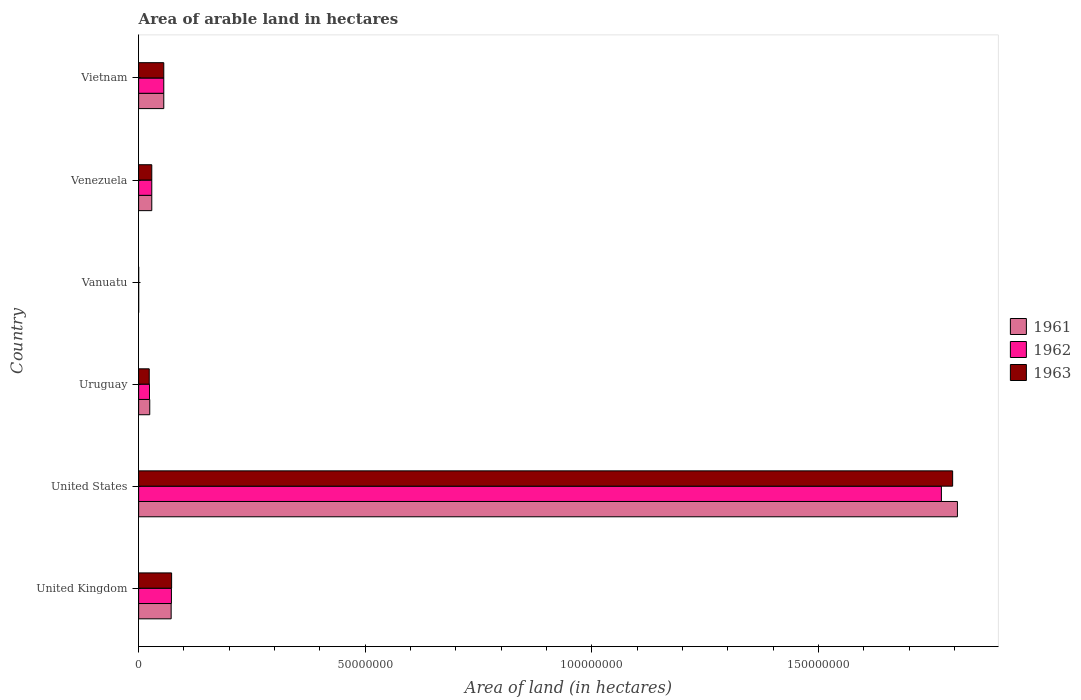How many different coloured bars are there?
Make the answer very short. 3. Are the number of bars per tick equal to the number of legend labels?
Your answer should be very brief. Yes. How many bars are there on the 3rd tick from the top?
Make the answer very short. 3. In how many cases, is the number of bars for a given country not equal to the number of legend labels?
Offer a terse response. 0. Across all countries, what is the maximum total arable land in 1962?
Make the answer very short. 1.77e+08. Across all countries, what is the minimum total arable land in 1961?
Your answer should be compact. 10000. In which country was the total arable land in 1963 minimum?
Ensure brevity in your answer.  Vanuatu. What is the total total arable land in 1963 in the graph?
Your response must be concise. 1.98e+08. What is the difference between the total arable land in 1963 in Uruguay and that in Vanuatu?
Ensure brevity in your answer.  2.33e+06. What is the difference between the total arable land in 1963 in United Kingdom and the total arable land in 1961 in Vanuatu?
Keep it short and to the point. 7.26e+06. What is the average total arable land in 1963 per country?
Keep it short and to the point. 3.29e+07. What is the difference between the total arable land in 1963 and total arable land in 1962 in Uruguay?
Keep it short and to the point. -5.80e+04. What is the ratio of the total arable land in 1962 in United States to that in Venezuela?
Keep it short and to the point. 61.07. What is the difference between the highest and the second highest total arable land in 1962?
Your answer should be very brief. 1.70e+08. What is the difference between the highest and the lowest total arable land in 1963?
Your answer should be very brief. 1.80e+08. In how many countries, is the total arable land in 1962 greater than the average total arable land in 1962 taken over all countries?
Ensure brevity in your answer.  1. What does the 3rd bar from the top in Vanuatu represents?
Your answer should be compact. 1961. Is it the case that in every country, the sum of the total arable land in 1961 and total arable land in 1963 is greater than the total arable land in 1962?
Your answer should be very brief. Yes. How many countries are there in the graph?
Provide a short and direct response. 6. What is the difference between two consecutive major ticks on the X-axis?
Your answer should be compact. 5.00e+07. Are the values on the major ticks of X-axis written in scientific E-notation?
Your response must be concise. No. Does the graph contain any zero values?
Offer a very short reply. No. Where does the legend appear in the graph?
Ensure brevity in your answer.  Center right. What is the title of the graph?
Your answer should be very brief. Area of arable land in hectares. What is the label or title of the X-axis?
Give a very brief answer. Area of land (in hectares). What is the label or title of the Y-axis?
Your answer should be very brief. Country. What is the Area of land (in hectares) of 1961 in United Kingdom?
Provide a short and direct response. 7.18e+06. What is the Area of land (in hectares) of 1962 in United Kingdom?
Offer a terse response. 7.24e+06. What is the Area of land (in hectares) of 1963 in United Kingdom?
Provide a succinct answer. 7.28e+06. What is the Area of land (in hectares) in 1961 in United States?
Your response must be concise. 1.81e+08. What is the Area of land (in hectares) in 1962 in United States?
Make the answer very short. 1.77e+08. What is the Area of land (in hectares) of 1963 in United States?
Your response must be concise. 1.80e+08. What is the Area of land (in hectares) of 1961 in Uruguay?
Ensure brevity in your answer.  2.45e+06. What is the Area of land (in hectares) in 1962 in Uruguay?
Your response must be concise. 2.40e+06. What is the Area of land (in hectares) of 1963 in Uruguay?
Provide a short and direct response. 2.34e+06. What is the Area of land (in hectares) of 1963 in Vanuatu?
Your answer should be very brief. 10000. What is the Area of land (in hectares) of 1961 in Venezuela?
Your answer should be very brief. 2.90e+06. What is the Area of land (in hectares) of 1962 in Venezuela?
Provide a succinct answer. 2.90e+06. What is the Area of land (in hectares) of 1963 in Venezuela?
Provide a short and direct response. 2.90e+06. What is the Area of land (in hectares) of 1961 in Vietnam?
Your answer should be compact. 5.55e+06. What is the Area of land (in hectares) in 1962 in Vietnam?
Ensure brevity in your answer.  5.55e+06. What is the Area of land (in hectares) of 1963 in Vietnam?
Provide a short and direct response. 5.55e+06. Across all countries, what is the maximum Area of land (in hectares) of 1961?
Give a very brief answer. 1.81e+08. Across all countries, what is the maximum Area of land (in hectares) in 1962?
Give a very brief answer. 1.77e+08. Across all countries, what is the maximum Area of land (in hectares) in 1963?
Provide a short and direct response. 1.80e+08. Across all countries, what is the minimum Area of land (in hectares) of 1961?
Keep it short and to the point. 10000. Across all countries, what is the minimum Area of land (in hectares) of 1963?
Make the answer very short. 10000. What is the total Area of land (in hectares) in 1961 in the graph?
Your answer should be very brief. 1.99e+08. What is the total Area of land (in hectares) in 1962 in the graph?
Ensure brevity in your answer.  1.95e+08. What is the total Area of land (in hectares) of 1963 in the graph?
Ensure brevity in your answer.  1.98e+08. What is the difference between the Area of land (in hectares) in 1961 in United Kingdom and that in United States?
Your response must be concise. -1.73e+08. What is the difference between the Area of land (in hectares) of 1962 in United Kingdom and that in United States?
Keep it short and to the point. -1.70e+08. What is the difference between the Area of land (in hectares) in 1963 in United Kingdom and that in United States?
Keep it short and to the point. -1.72e+08. What is the difference between the Area of land (in hectares) in 1961 in United Kingdom and that in Uruguay?
Keep it short and to the point. 4.72e+06. What is the difference between the Area of land (in hectares) in 1962 in United Kingdom and that in Uruguay?
Your answer should be very brief. 4.84e+06. What is the difference between the Area of land (in hectares) in 1963 in United Kingdom and that in Uruguay?
Offer a terse response. 4.94e+06. What is the difference between the Area of land (in hectares) of 1961 in United Kingdom and that in Vanuatu?
Provide a short and direct response. 7.16e+06. What is the difference between the Area of land (in hectares) of 1962 in United Kingdom and that in Vanuatu?
Keep it short and to the point. 7.23e+06. What is the difference between the Area of land (in hectares) of 1963 in United Kingdom and that in Vanuatu?
Give a very brief answer. 7.26e+06. What is the difference between the Area of land (in hectares) in 1961 in United Kingdom and that in Venezuela?
Your answer should be very brief. 4.28e+06. What is the difference between the Area of land (in hectares) in 1962 in United Kingdom and that in Venezuela?
Ensure brevity in your answer.  4.34e+06. What is the difference between the Area of land (in hectares) in 1963 in United Kingdom and that in Venezuela?
Give a very brief answer. 4.37e+06. What is the difference between the Area of land (in hectares) of 1961 in United Kingdom and that in Vietnam?
Provide a succinct answer. 1.62e+06. What is the difference between the Area of land (in hectares) in 1962 in United Kingdom and that in Vietnam?
Ensure brevity in your answer.  1.69e+06. What is the difference between the Area of land (in hectares) of 1963 in United Kingdom and that in Vietnam?
Ensure brevity in your answer.  1.72e+06. What is the difference between the Area of land (in hectares) of 1961 in United States and that in Uruguay?
Keep it short and to the point. 1.78e+08. What is the difference between the Area of land (in hectares) of 1962 in United States and that in Uruguay?
Offer a very short reply. 1.75e+08. What is the difference between the Area of land (in hectares) of 1963 in United States and that in Uruguay?
Your response must be concise. 1.77e+08. What is the difference between the Area of land (in hectares) of 1961 in United States and that in Vanuatu?
Your answer should be very brief. 1.81e+08. What is the difference between the Area of land (in hectares) in 1962 in United States and that in Vanuatu?
Provide a short and direct response. 1.77e+08. What is the difference between the Area of land (in hectares) in 1963 in United States and that in Vanuatu?
Provide a short and direct response. 1.80e+08. What is the difference between the Area of land (in hectares) of 1961 in United States and that in Venezuela?
Your response must be concise. 1.78e+08. What is the difference between the Area of land (in hectares) in 1962 in United States and that in Venezuela?
Your response must be concise. 1.74e+08. What is the difference between the Area of land (in hectares) in 1963 in United States and that in Venezuela?
Ensure brevity in your answer.  1.77e+08. What is the difference between the Area of land (in hectares) in 1961 in United States and that in Vietnam?
Provide a succinct answer. 1.75e+08. What is the difference between the Area of land (in hectares) in 1962 in United States and that in Vietnam?
Keep it short and to the point. 1.72e+08. What is the difference between the Area of land (in hectares) of 1963 in United States and that in Vietnam?
Make the answer very short. 1.74e+08. What is the difference between the Area of land (in hectares) in 1961 in Uruguay and that in Vanuatu?
Your answer should be compact. 2.44e+06. What is the difference between the Area of land (in hectares) in 1962 in Uruguay and that in Vanuatu?
Your answer should be very brief. 2.39e+06. What is the difference between the Area of land (in hectares) in 1963 in Uruguay and that in Vanuatu?
Offer a very short reply. 2.33e+06. What is the difference between the Area of land (in hectares) of 1961 in Uruguay and that in Venezuela?
Provide a short and direct response. -4.46e+05. What is the difference between the Area of land (in hectares) in 1962 in Uruguay and that in Venezuela?
Ensure brevity in your answer.  -5.04e+05. What is the difference between the Area of land (in hectares) of 1963 in Uruguay and that in Venezuela?
Keep it short and to the point. -5.65e+05. What is the difference between the Area of land (in hectares) of 1961 in Uruguay and that in Vietnam?
Provide a succinct answer. -3.10e+06. What is the difference between the Area of land (in hectares) in 1962 in Uruguay and that in Vietnam?
Provide a succinct answer. -3.15e+06. What is the difference between the Area of land (in hectares) of 1963 in Uruguay and that in Vietnam?
Your answer should be very brief. -3.21e+06. What is the difference between the Area of land (in hectares) in 1961 in Vanuatu and that in Venezuela?
Provide a short and direct response. -2.89e+06. What is the difference between the Area of land (in hectares) of 1962 in Vanuatu and that in Venezuela?
Keep it short and to the point. -2.89e+06. What is the difference between the Area of land (in hectares) of 1963 in Vanuatu and that in Venezuela?
Offer a terse response. -2.89e+06. What is the difference between the Area of land (in hectares) in 1961 in Vanuatu and that in Vietnam?
Your response must be concise. -5.54e+06. What is the difference between the Area of land (in hectares) of 1962 in Vanuatu and that in Vietnam?
Your answer should be compact. -5.54e+06. What is the difference between the Area of land (in hectares) in 1963 in Vanuatu and that in Vietnam?
Provide a succinct answer. -5.54e+06. What is the difference between the Area of land (in hectares) in 1961 in Venezuela and that in Vietnam?
Make the answer very short. -2.65e+06. What is the difference between the Area of land (in hectares) of 1962 in Venezuela and that in Vietnam?
Make the answer very short. -2.65e+06. What is the difference between the Area of land (in hectares) in 1963 in Venezuela and that in Vietnam?
Your response must be concise. -2.65e+06. What is the difference between the Area of land (in hectares) in 1961 in United Kingdom and the Area of land (in hectares) in 1962 in United States?
Your answer should be very brief. -1.70e+08. What is the difference between the Area of land (in hectares) in 1961 in United Kingdom and the Area of land (in hectares) in 1963 in United States?
Offer a very short reply. -1.72e+08. What is the difference between the Area of land (in hectares) of 1962 in United Kingdom and the Area of land (in hectares) of 1963 in United States?
Provide a short and direct response. -1.72e+08. What is the difference between the Area of land (in hectares) in 1961 in United Kingdom and the Area of land (in hectares) in 1962 in Uruguay?
Provide a short and direct response. 4.78e+06. What is the difference between the Area of land (in hectares) in 1961 in United Kingdom and the Area of land (in hectares) in 1963 in Uruguay?
Your answer should be very brief. 4.84e+06. What is the difference between the Area of land (in hectares) of 1962 in United Kingdom and the Area of land (in hectares) of 1963 in Uruguay?
Offer a terse response. 4.90e+06. What is the difference between the Area of land (in hectares) of 1961 in United Kingdom and the Area of land (in hectares) of 1962 in Vanuatu?
Offer a very short reply. 7.16e+06. What is the difference between the Area of land (in hectares) of 1961 in United Kingdom and the Area of land (in hectares) of 1963 in Vanuatu?
Provide a short and direct response. 7.16e+06. What is the difference between the Area of land (in hectares) in 1962 in United Kingdom and the Area of land (in hectares) in 1963 in Vanuatu?
Your answer should be very brief. 7.23e+06. What is the difference between the Area of land (in hectares) in 1961 in United Kingdom and the Area of land (in hectares) in 1962 in Venezuela?
Provide a succinct answer. 4.28e+06. What is the difference between the Area of land (in hectares) in 1961 in United Kingdom and the Area of land (in hectares) in 1963 in Venezuela?
Ensure brevity in your answer.  4.27e+06. What is the difference between the Area of land (in hectares) of 1962 in United Kingdom and the Area of land (in hectares) of 1963 in Venezuela?
Give a very brief answer. 4.33e+06. What is the difference between the Area of land (in hectares) in 1961 in United Kingdom and the Area of land (in hectares) in 1962 in Vietnam?
Your answer should be very brief. 1.62e+06. What is the difference between the Area of land (in hectares) in 1961 in United Kingdom and the Area of land (in hectares) in 1963 in Vietnam?
Your response must be concise. 1.62e+06. What is the difference between the Area of land (in hectares) in 1962 in United Kingdom and the Area of land (in hectares) in 1963 in Vietnam?
Give a very brief answer. 1.69e+06. What is the difference between the Area of land (in hectares) of 1961 in United States and the Area of land (in hectares) of 1962 in Uruguay?
Your answer should be very brief. 1.78e+08. What is the difference between the Area of land (in hectares) of 1961 in United States and the Area of land (in hectares) of 1963 in Uruguay?
Provide a succinct answer. 1.78e+08. What is the difference between the Area of land (in hectares) of 1962 in United States and the Area of land (in hectares) of 1963 in Uruguay?
Offer a terse response. 1.75e+08. What is the difference between the Area of land (in hectares) of 1961 in United States and the Area of land (in hectares) of 1962 in Vanuatu?
Ensure brevity in your answer.  1.81e+08. What is the difference between the Area of land (in hectares) of 1961 in United States and the Area of land (in hectares) of 1963 in Vanuatu?
Ensure brevity in your answer.  1.81e+08. What is the difference between the Area of land (in hectares) in 1962 in United States and the Area of land (in hectares) in 1963 in Vanuatu?
Keep it short and to the point. 1.77e+08. What is the difference between the Area of land (in hectares) in 1961 in United States and the Area of land (in hectares) in 1962 in Venezuela?
Ensure brevity in your answer.  1.78e+08. What is the difference between the Area of land (in hectares) of 1961 in United States and the Area of land (in hectares) of 1963 in Venezuela?
Keep it short and to the point. 1.78e+08. What is the difference between the Area of land (in hectares) in 1962 in United States and the Area of land (in hectares) in 1963 in Venezuela?
Make the answer very short. 1.74e+08. What is the difference between the Area of land (in hectares) in 1961 in United States and the Area of land (in hectares) in 1962 in Vietnam?
Keep it short and to the point. 1.75e+08. What is the difference between the Area of land (in hectares) in 1961 in United States and the Area of land (in hectares) in 1963 in Vietnam?
Your answer should be very brief. 1.75e+08. What is the difference between the Area of land (in hectares) of 1962 in United States and the Area of land (in hectares) of 1963 in Vietnam?
Your answer should be very brief. 1.72e+08. What is the difference between the Area of land (in hectares) of 1961 in Uruguay and the Area of land (in hectares) of 1962 in Vanuatu?
Offer a terse response. 2.44e+06. What is the difference between the Area of land (in hectares) in 1961 in Uruguay and the Area of land (in hectares) in 1963 in Vanuatu?
Offer a very short reply. 2.44e+06. What is the difference between the Area of land (in hectares) of 1962 in Uruguay and the Area of land (in hectares) of 1963 in Vanuatu?
Your answer should be very brief. 2.39e+06. What is the difference between the Area of land (in hectares) in 1961 in Uruguay and the Area of land (in hectares) in 1962 in Venezuela?
Your response must be concise. -4.46e+05. What is the difference between the Area of land (in hectares) in 1961 in Uruguay and the Area of land (in hectares) in 1963 in Venezuela?
Your response must be concise. -4.49e+05. What is the difference between the Area of land (in hectares) in 1962 in Uruguay and the Area of land (in hectares) in 1963 in Venezuela?
Ensure brevity in your answer.  -5.07e+05. What is the difference between the Area of land (in hectares) in 1961 in Uruguay and the Area of land (in hectares) in 1962 in Vietnam?
Provide a succinct answer. -3.10e+06. What is the difference between the Area of land (in hectares) in 1961 in Uruguay and the Area of land (in hectares) in 1963 in Vietnam?
Keep it short and to the point. -3.10e+06. What is the difference between the Area of land (in hectares) of 1962 in Uruguay and the Area of land (in hectares) of 1963 in Vietnam?
Keep it short and to the point. -3.15e+06. What is the difference between the Area of land (in hectares) in 1961 in Vanuatu and the Area of land (in hectares) in 1962 in Venezuela?
Offer a very short reply. -2.89e+06. What is the difference between the Area of land (in hectares) of 1961 in Vanuatu and the Area of land (in hectares) of 1963 in Venezuela?
Offer a terse response. -2.89e+06. What is the difference between the Area of land (in hectares) of 1962 in Vanuatu and the Area of land (in hectares) of 1963 in Venezuela?
Provide a succinct answer. -2.89e+06. What is the difference between the Area of land (in hectares) of 1961 in Vanuatu and the Area of land (in hectares) of 1962 in Vietnam?
Make the answer very short. -5.54e+06. What is the difference between the Area of land (in hectares) in 1961 in Vanuatu and the Area of land (in hectares) in 1963 in Vietnam?
Offer a very short reply. -5.54e+06. What is the difference between the Area of land (in hectares) in 1962 in Vanuatu and the Area of land (in hectares) in 1963 in Vietnam?
Offer a terse response. -5.54e+06. What is the difference between the Area of land (in hectares) in 1961 in Venezuela and the Area of land (in hectares) in 1962 in Vietnam?
Offer a very short reply. -2.65e+06. What is the difference between the Area of land (in hectares) in 1961 in Venezuela and the Area of land (in hectares) in 1963 in Vietnam?
Offer a very short reply. -2.65e+06. What is the difference between the Area of land (in hectares) of 1962 in Venezuela and the Area of land (in hectares) of 1963 in Vietnam?
Give a very brief answer. -2.65e+06. What is the average Area of land (in hectares) in 1961 per country?
Your response must be concise. 3.31e+07. What is the average Area of land (in hectares) in 1962 per country?
Ensure brevity in your answer.  3.25e+07. What is the average Area of land (in hectares) in 1963 per country?
Give a very brief answer. 3.29e+07. What is the difference between the Area of land (in hectares) of 1961 and Area of land (in hectares) of 1962 in United Kingdom?
Provide a short and direct response. -6.10e+04. What is the difference between the Area of land (in hectares) of 1961 and Area of land (in hectares) of 1963 in United Kingdom?
Your answer should be very brief. -1.00e+05. What is the difference between the Area of land (in hectares) in 1962 and Area of land (in hectares) in 1963 in United Kingdom?
Offer a very short reply. -3.90e+04. What is the difference between the Area of land (in hectares) of 1961 and Area of land (in hectares) of 1962 in United States?
Ensure brevity in your answer.  3.54e+06. What is the difference between the Area of land (in hectares) in 1961 and Area of land (in hectares) in 1963 in United States?
Your answer should be very brief. 1.06e+06. What is the difference between the Area of land (in hectares) in 1962 and Area of land (in hectares) in 1963 in United States?
Ensure brevity in your answer.  -2.48e+06. What is the difference between the Area of land (in hectares) of 1961 and Area of land (in hectares) of 1962 in Uruguay?
Provide a succinct answer. 5.80e+04. What is the difference between the Area of land (in hectares) in 1961 and Area of land (in hectares) in 1963 in Uruguay?
Offer a very short reply. 1.16e+05. What is the difference between the Area of land (in hectares) of 1962 and Area of land (in hectares) of 1963 in Uruguay?
Provide a succinct answer. 5.80e+04. What is the difference between the Area of land (in hectares) in 1961 and Area of land (in hectares) in 1962 in Vanuatu?
Your response must be concise. 0. What is the difference between the Area of land (in hectares) in 1961 and Area of land (in hectares) in 1963 in Vanuatu?
Your answer should be very brief. 0. What is the difference between the Area of land (in hectares) of 1961 and Area of land (in hectares) of 1963 in Venezuela?
Provide a short and direct response. -3000. What is the difference between the Area of land (in hectares) of 1962 and Area of land (in hectares) of 1963 in Venezuela?
Your answer should be compact. -3000. What is the difference between the Area of land (in hectares) of 1962 and Area of land (in hectares) of 1963 in Vietnam?
Offer a very short reply. 0. What is the ratio of the Area of land (in hectares) of 1961 in United Kingdom to that in United States?
Make the answer very short. 0.04. What is the ratio of the Area of land (in hectares) in 1962 in United Kingdom to that in United States?
Your answer should be very brief. 0.04. What is the ratio of the Area of land (in hectares) of 1963 in United Kingdom to that in United States?
Offer a terse response. 0.04. What is the ratio of the Area of land (in hectares) in 1961 in United Kingdom to that in Uruguay?
Keep it short and to the point. 2.92. What is the ratio of the Area of land (in hectares) of 1962 in United Kingdom to that in Uruguay?
Your answer should be very brief. 3.02. What is the ratio of the Area of land (in hectares) of 1963 in United Kingdom to that in Uruguay?
Your answer should be very brief. 3.11. What is the ratio of the Area of land (in hectares) in 1961 in United Kingdom to that in Vanuatu?
Your answer should be very brief. 717.5. What is the ratio of the Area of land (in hectares) of 1962 in United Kingdom to that in Vanuatu?
Provide a short and direct response. 723.6. What is the ratio of the Area of land (in hectares) in 1963 in United Kingdom to that in Vanuatu?
Your answer should be compact. 727.5. What is the ratio of the Area of land (in hectares) in 1961 in United Kingdom to that in Venezuela?
Keep it short and to the point. 2.47. What is the ratio of the Area of land (in hectares) of 1962 in United Kingdom to that in Venezuela?
Provide a succinct answer. 2.5. What is the ratio of the Area of land (in hectares) in 1963 in United Kingdom to that in Venezuela?
Offer a terse response. 2.51. What is the ratio of the Area of land (in hectares) of 1961 in United Kingdom to that in Vietnam?
Provide a short and direct response. 1.29. What is the ratio of the Area of land (in hectares) in 1962 in United Kingdom to that in Vietnam?
Offer a terse response. 1.3. What is the ratio of the Area of land (in hectares) in 1963 in United Kingdom to that in Vietnam?
Your answer should be very brief. 1.31. What is the ratio of the Area of land (in hectares) of 1961 in United States to that in Uruguay?
Keep it short and to the point. 73.61. What is the ratio of the Area of land (in hectares) in 1962 in United States to that in Uruguay?
Make the answer very short. 73.91. What is the ratio of the Area of land (in hectares) in 1963 in United States to that in Uruguay?
Your answer should be compact. 76.81. What is the ratio of the Area of land (in hectares) in 1961 in United States to that in Vanuatu?
Provide a short and direct response. 1.81e+04. What is the ratio of the Area of land (in hectares) of 1962 in United States to that in Vanuatu?
Offer a very short reply. 1.77e+04. What is the ratio of the Area of land (in hectares) of 1963 in United States to that in Vanuatu?
Make the answer very short. 1.80e+04. What is the ratio of the Area of land (in hectares) in 1961 in United States to that in Venezuela?
Offer a terse response. 62.29. What is the ratio of the Area of land (in hectares) of 1962 in United States to that in Venezuela?
Give a very brief answer. 61.07. What is the ratio of the Area of land (in hectares) of 1963 in United States to that in Venezuela?
Offer a terse response. 61.86. What is the ratio of the Area of land (in hectares) in 1961 in United States to that in Vietnam?
Ensure brevity in your answer.  32.55. What is the ratio of the Area of land (in hectares) of 1962 in United States to that in Vietnam?
Your response must be concise. 31.91. What is the ratio of the Area of land (in hectares) of 1963 in United States to that in Vietnam?
Your response must be concise. 32.36. What is the ratio of the Area of land (in hectares) in 1961 in Uruguay to that in Vanuatu?
Your answer should be compact. 245.4. What is the ratio of the Area of land (in hectares) of 1962 in Uruguay to that in Vanuatu?
Provide a short and direct response. 239.6. What is the ratio of the Area of land (in hectares) of 1963 in Uruguay to that in Vanuatu?
Ensure brevity in your answer.  233.8. What is the ratio of the Area of land (in hectares) in 1961 in Uruguay to that in Venezuela?
Your answer should be very brief. 0.85. What is the ratio of the Area of land (in hectares) in 1962 in Uruguay to that in Venezuela?
Provide a short and direct response. 0.83. What is the ratio of the Area of land (in hectares) of 1963 in Uruguay to that in Venezuela?
Your answer should be compact. 0.81. What is the ratio of the Area of land (in hectares) of 1961 in Uruguay to that in Vietnam?
Provide a short and direct response. 0.44. What is the ratio of the Area of land (in hectares) in 1962 in Uruguay to that in Vietnam?
Keep it short and to the point. 0.43. What is the ratio of the Area of land (in hectares) in 1963 in Uruguay to that in Vietnam?
Keep it short and to the point. 0.42. What is the ratio of the Area of land (in hectares) of 1961 in Vanuatu to that in Venezuela?
Provide a succinct answer. 0. What is the ratio of the Area of land (in hectares) in 1962 in Vanuatu to that in Venezuela?
Keep it short and to the point. 0. What is the ratio of the Area of land (in hectares) in 1963 in Vanuatu to that in Venezuela?
Keep it short and to the point. 0. What is the ratio of the Area of land (in hectares) of 1961 in Vanuatu to that in Vietnam?
Your answer should be compact. 0. What is the ratio of the Area of land (in hectares) of 1962 in Vanuatu to that in Vietnam?
Provide a short and direct response. 0. What is the ratio of the Area of land (in hectares) of 1963 in Vanuatu to that in Vietnam?
Keep it short and to the point. 0. What is the ratio of the Area of land (in hectares) in 1961 in Venezuela to that in Vietnam?
Your response must be concise. 0.52. What is the ratio of the Area of land (in hectares) in 1962 in Venezuela to that in Vietnam?
Offer a very short reply. 0.52. What is the ratio of the Area of land (in hectares) of 1963 in Venezuela to that in Vietnam?
Provide a short and direct response. 0.52. What is the difference between the highest and the second highest Area of land (in hectares) in 1961?
Offer a terse response. 1.73e+08. What is the difference between the highest and the second highest Area of land (in hectares) in 1962?
Your answer should be compact. 1.70e+08. What is the difference between the highest and the second highest Area of land (in hectares) of 1963?
Offer a terse response. 1.72e+08. What is the difference between the highest and the lowest Area of land (in hectares) of 1961?
Provide a short and direct response. 1.81e+08. What is the difference between the highest and the lowest Area of land (in hectares) of 1962?
Your response must be concise. 1.77e+08. What is the difference between the highest and the lowest Area of land (in hectares) in 1963?
Make the answer very short. 1.80e+08. 